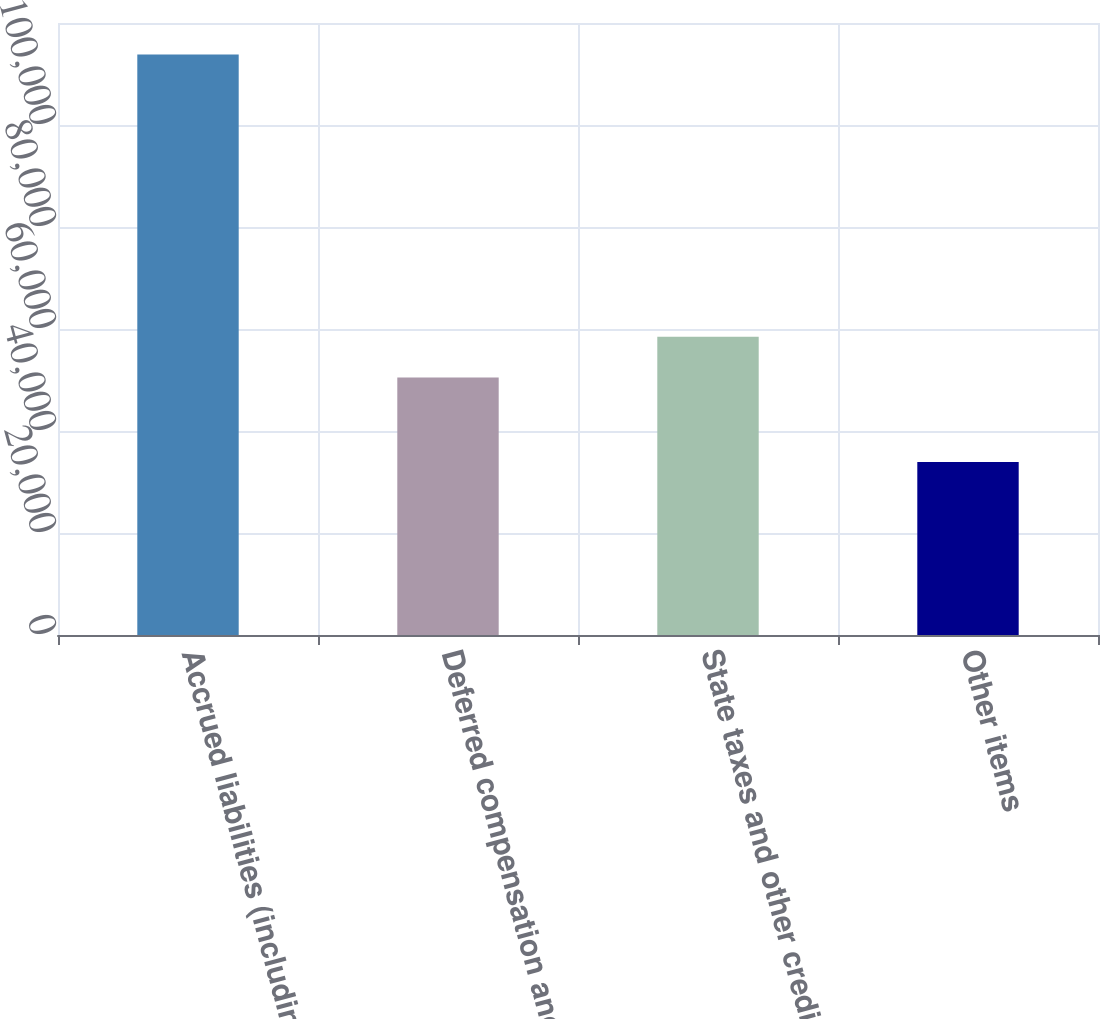Convert chart. <chart><loc_0><loc_0><loc_500><loc_500><bar_chart><fcel>Accrued liabilities (including<fcel>Deferred compensation and<fcel>State taxes and other credits<fcel>Other items<nl><fcel>113845<fcel>50500<fcel>58490.8<fcel>33937<nl></chart> 